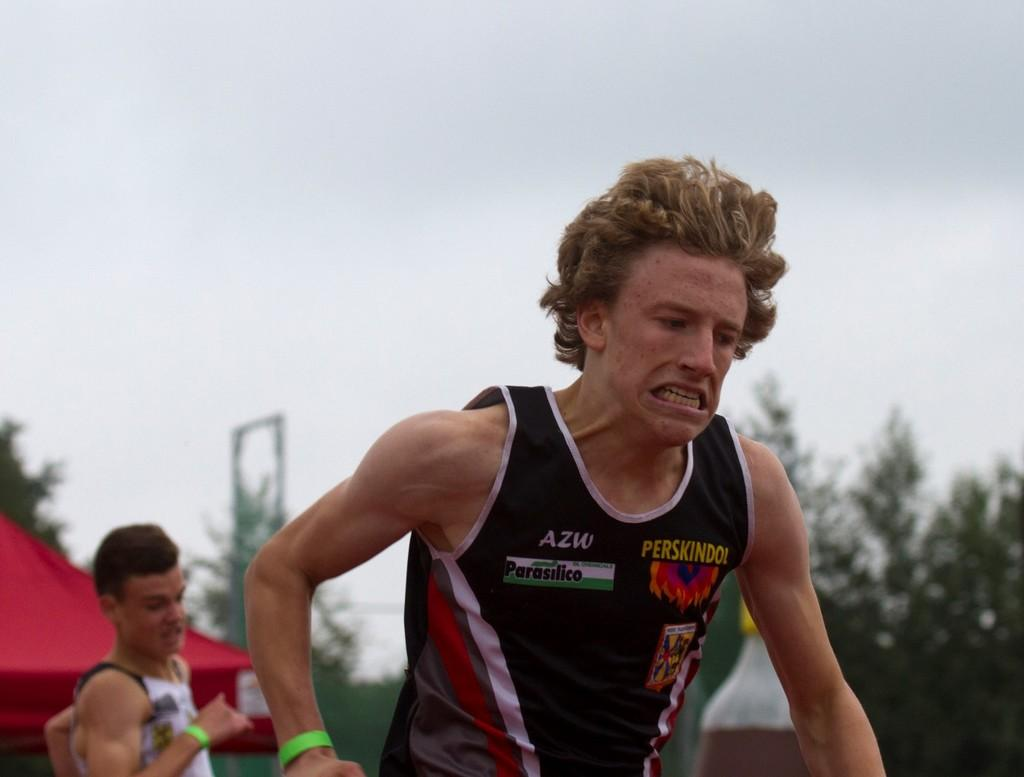What are the two men in the image doing? The two men in the image are running. What can be seen in the background of the image? There are trees and the sky visible in the background of the image. How is the background of the image depicted? The background of the image is blurred. What type of patch can be seen on the body of one of the men in the image? There is no patch visible on the body of either man in the image. 